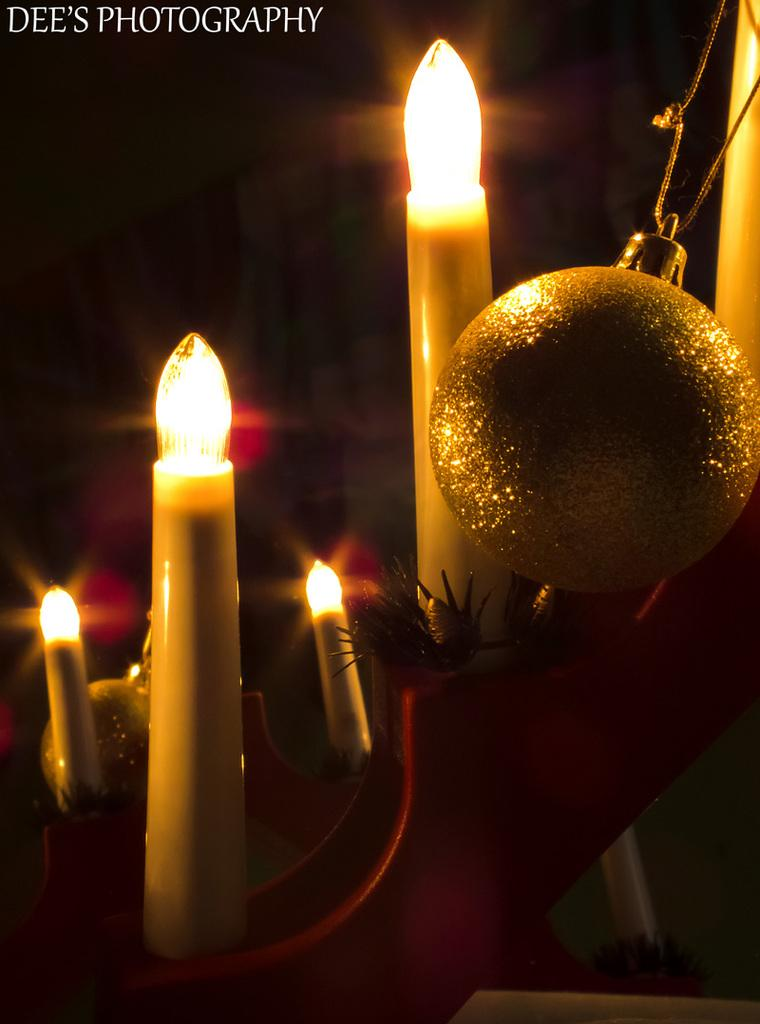What type of objects can be seen in the image? There are candles and a decorative ball in the image. Are there any other objects present in the image? Yes, there are other objects in the image. What is the color of the background in the image? The background of the image is dark. Is there any text or writing in the image? Yes, there is writing at the top of the image. What type of corn can be seen growing in the image? There is no corn present in the image. Is there a collar visible on any of the objects in the image? There is no collar visible on any of the objects in the image. 